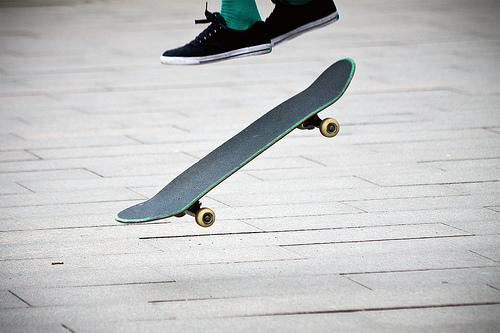Count the number of stone tiles on the floor in the image. There are 10 stone tiles on the floor. How many wheels of the skateboard are visible, and what color are they? There are four visible wheels, and they are all white. Mention the object that is the focus of the image. A skateboard popped in the air by a skateboarder wearing green socks and black and white shoes. What footwear is the skateboarder wearing, and what is unique about them? The skateboarder is wearing black and white skateboard shoes with white soles and black shoelaces. What type of ground surface is under the skateboard and the person? A brick ground surface with stone tiles. In one sentence, explain the main action depicted in the image. A skateboarder wearing green socks and black and white shoes has jumped into the air, popping their black and green skateboard above the brick flooring. Describe the surface the skateboard is jumping over. The skateboard is jumping over a concrete brick ground with multiple stone tiles. Identify the objects on the ground, other than the stone tiles. There are a brick flooring, a shadow, and a cigarette butt on the ground. What color are the socks of the person jumping in the air? The socks are green. 